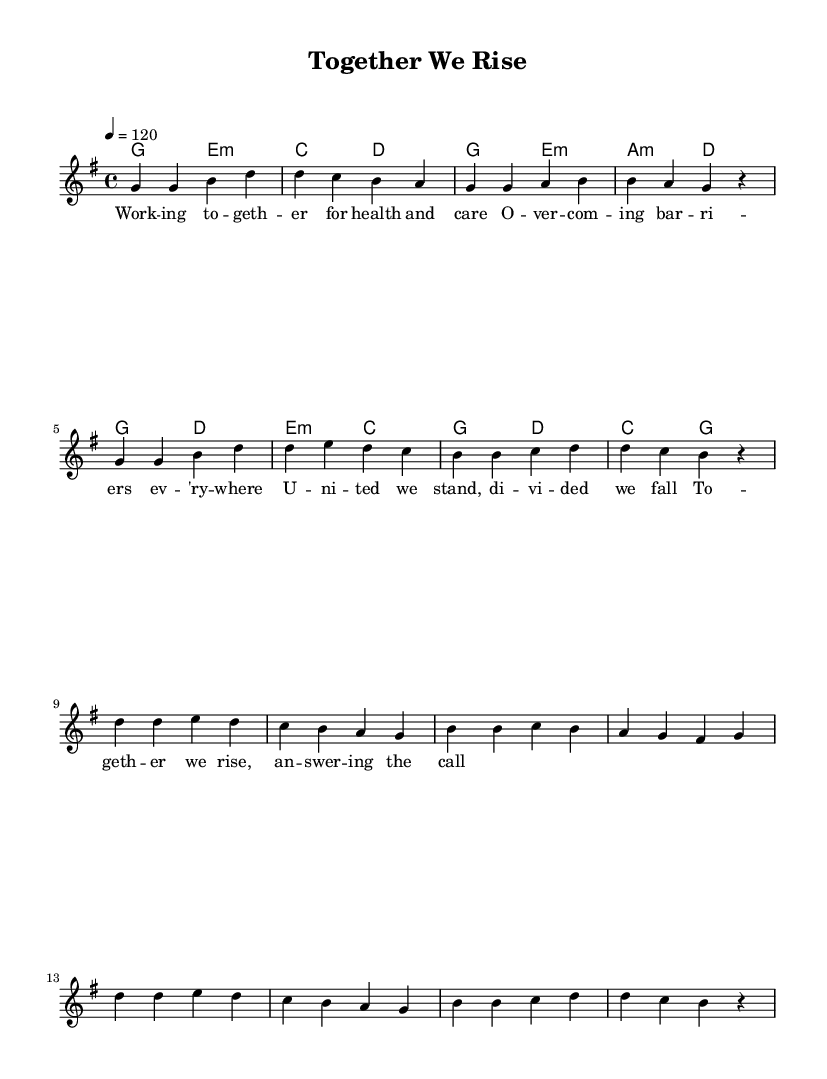What is the key signature of this music? The key signature is G major, which has one sharp (F#).
Answer: G major What is the time signature of this music? The time signature is 4/4, indicating four beats per measure.
Answer: 4/4 What is the tempo marking of this music? The tempo marking is 120 beats per minute, written as 4 = 120.
Answer: 120 How many measures are in the verse section? The verse section contains 8 measures, each indicated by the music notation and slurs.
Answer: 8 measures What is the main theme of the lyrics? The main theme of the lyrics focuses on collaboration and overcoming barriers for health and care in the community.
Answer: Community support What chord follows the initial melody in the verse? The first chord in the verse is G major, which is indicated right at the beginning of the section.
Answer: G major How does the chorus contrast with the verse musically? The chorus features a different melodic line and emotional emphasis on unity, as well as changes in harmony compared to the verse.
Answer: Different melody 